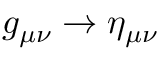Convert formula to latex. <formula><loc_0><loc_0><loc_500><loc_500>g _ { \mu \nu } \rightarrow \eta _ { \mu \nu }</formula> 